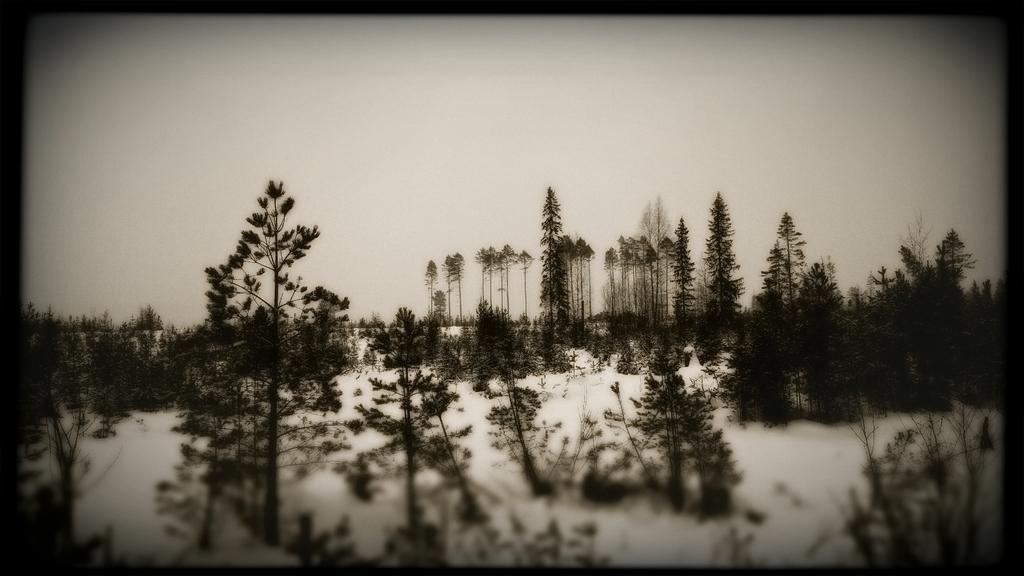Could you give a brief overview of what you see in this image? It looks like a black and white picture. We can see there are trees, snow and a sky. 